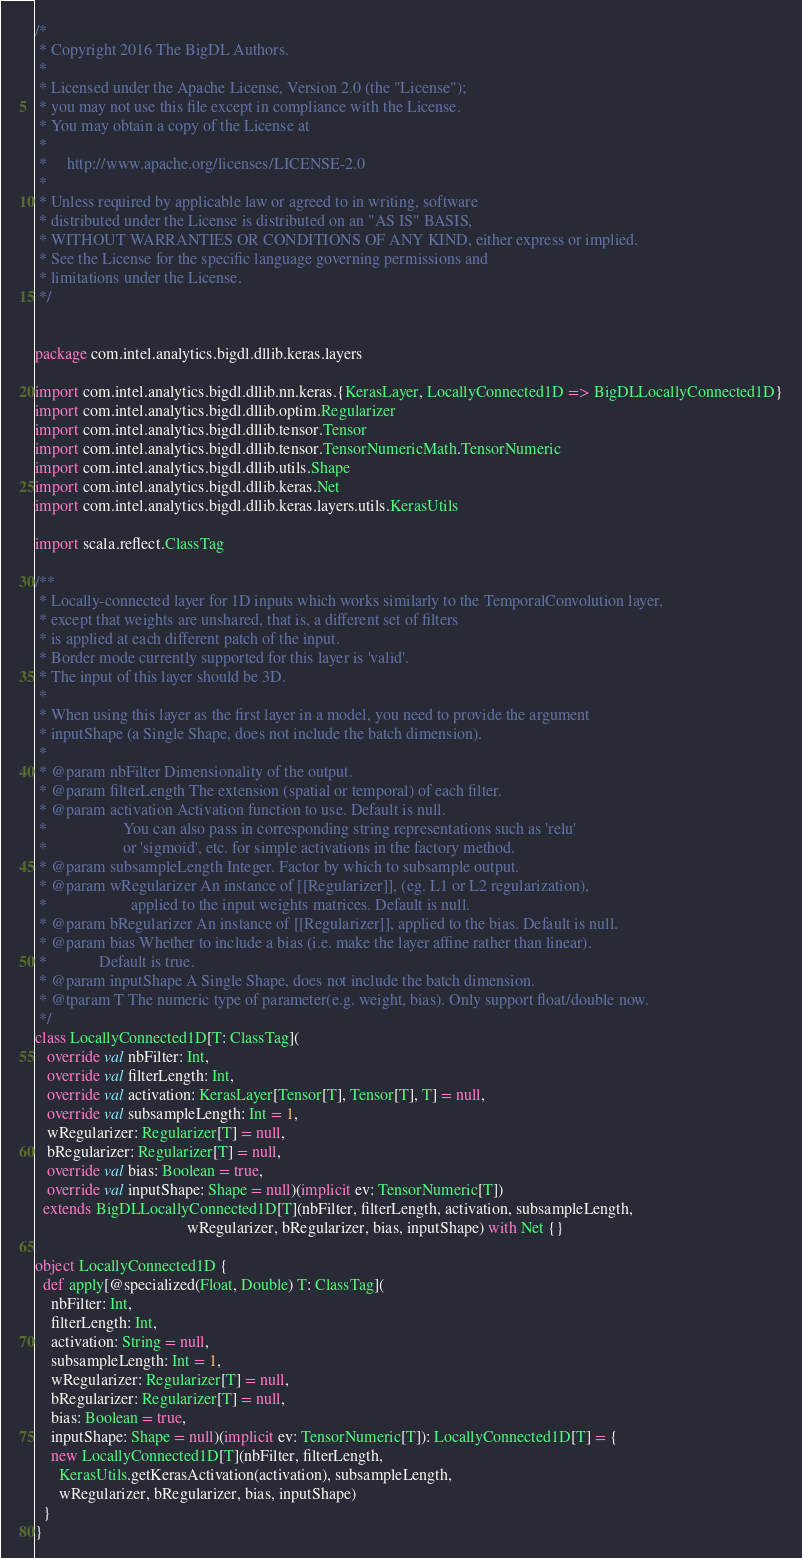Convert code to text. <code><loc_0><loc_0><loc_500><loc_500><_Scala_>/*
 * Copyright 2016 The BigDL Authors.
 *
 * Licensed under the Apache License, Version 2.0 (the "License");
 * you may not use this file except in compliance with the License.
 * You may obtain a copy of the License at
 *
 *     http://www.apache.org/licenses/LICENSE-2.0
 *
 * Unless required by applicable law or agreed to in writing, software
 * distributed under the License is distributed on an "AS IS" BASIS,
 * WITHOUT WARRANTIES OR CONDITIONS OF ANY KIND, either express or implied.
 * See the License for the specific language governing permissions and
 * limitations under the License.
 */


package com.intel.analytics.bigdl.dllib.keras.layers

import com.intel.analytics.bigdl.dllib.nn.keras.{KerasLayer, LocallyConnected1D => BigDLLocallyConnected1D}
import com.intel.analytics.bigdl.dllib.optim.Regularizer
import com.intel.analytics.bigdl.dllib.tensor.Tensor
import com.intel.analytics.bigdl.dllib.tensor.TensorNumericMath.TensorNumeric
import com.intel.analytics.bigdl.dllib.utils.Shape
import com.intel.analytics.bigdl.dllib.keras.Net
import com.intel.analytics.bigdl.dllib.keras.layers.utils.KerasUtils

import scala.reflect.ClassTag

/**
 * Locally-connected layer for 1D inputs which works similarly to the TemporalConvolution layer,
 * except that weights are unshared, that is, a different set of filters
 * is applied at each different patch of the input.
 * Border mode currently supported for this layer is 'valid'.
 * The input of this layer should be 3D.
 *
 * When using this layer as the first layer in a model, you need to provide the argument
 * inputShape (a Single Shape, does not include the batch dimension).
 *
 * @param nbFilter Dimensionality of the output.
 * @param filterLength The extension (spatial or temporal) of each filter.
 * @param activation Activation function to use. Default is null.
 *                   You can also pass in corresponding string representations such as 'relu'
 *                   or 'sigmoid', etc. for simple activations in the factory method.
 * @param subsampleLength Integer. Factor by which to subsample output.
 * @param wRegularizer An instance of [[Regularizer]], (eg. L1 or L2 regularization),
 *                     applied to the input weights matrices. Default is null.
 * @param bRegularizer An instance of [[Regularizer]], applied to the bias. Default is null.
 * @param bias Whether to include a bias (i.e. make the layer affine rather than linear).
 *             Default is true.
 * @param inputShape A Single Shape, does not include the batch dimension.
 * @tparam T The numeric type of parameter(e.g. weight, bias). Only support float/double now.
 */
class LocallyConnected1D[T: ClassTag](
   override val nbFilter: Int,
   override val filterLength: Int,
   override val activation: KerasLayer[Tensor[T], Tensor[T], T] = null,
   override val subsampleLength: Int = 1,
   wRegularizer: Regularizer[T] = null,
   bRegularizer: Regularizer[T] = null,
   override val bias: Boolean = true,
   override val inputShape: Shape = null)(implicit ev: TensorNumeric[T])
  extends BigDLLocallyConnected1D[T](nbFilter, filterLength, activation, subsampleLength,
                                      wRegularizer, bRegularizer, bias, inputShape) with Net {}

object LocallyConnected1D {
  def apply[@specialized(Float, Double) T: ClassTag](
    nbFilter: Int,
    filterLength: Int,
    activation: String = null,
    subsampleLength: Int = 1,
    wRegularizer: Regularizer[T] = null,
    bRegularizer: Regularizer[T] = null,
    bias: Boolean = true,
    inputShape: Shape = null)(implicit ev: TensorNumeric[T]): LocallyConnected1D[T] = {
    new LocallyConnected1D[T](nbFilter, filterLength,
      KerasUtils.getKerasActivation(activation), subsampleLength,
      wRegularizer, bRegularizer, bias, inputShape)
  }
}
</code> 